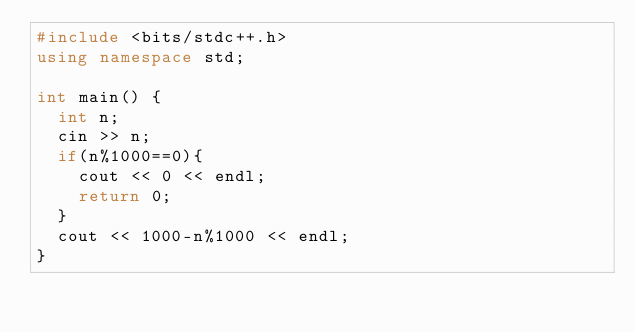<code> <loc_0><loc_0><loc_500><loc_500><_C++_>#include <bits/stdc++.h>
using namespace std;
 
int main() {
  int n;
  cin >> n;
  if(n%1000==0){
    cout << 0 << endl;
    return 0;
  }
  cout << 1000-n%1000 << endl;
}</code> 